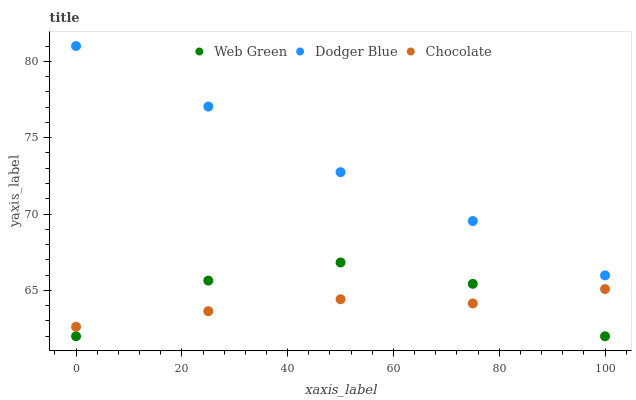Does Chocolate have the minimum area under the curve?
Answer yes or no. Yes. Does Dodger Blue have the maximum area under the curve?
Answer yes or no. Yes. Does Web Green have the minimum area under the curve?
Answer yes or no. No. Does Web Green have the maximum area under the curve?
Answer yes or no. No. Is Dodger Blue the smoothest?
Answer yes or no. Yes. Is Web Green the roughest?
Answer yes or no. Yes. Is Chocolate the smoothest?
Answer yes or no. No. Is Chocolate the roughest?
Answer yes or no. No. Does Web Green have the lowest value?
Answer yes or no. Yes. Does Chocolate have the lowest value?
Answer yes or no. No. Does Dodger Blue have the highest value?
Answer yes or no. Yes. Does Web Green have the highest value?
Answer yes or no. No. Is Web Green less than Dodger Blue?
Answer yes or no. Yes. Is Dodger Blue greater than Chocolate?
Answer yes or no. Yes. Does Web Green intersect Chocolate?
Answer yes or no. Yes. Is Web Green less than Chocolate?
Answer yes or no. No. Is Web Green greater than Chocolate?
Answer yes or no. No. Does Web Green intersect Dodger Blue?
Answer yes or no. No. 